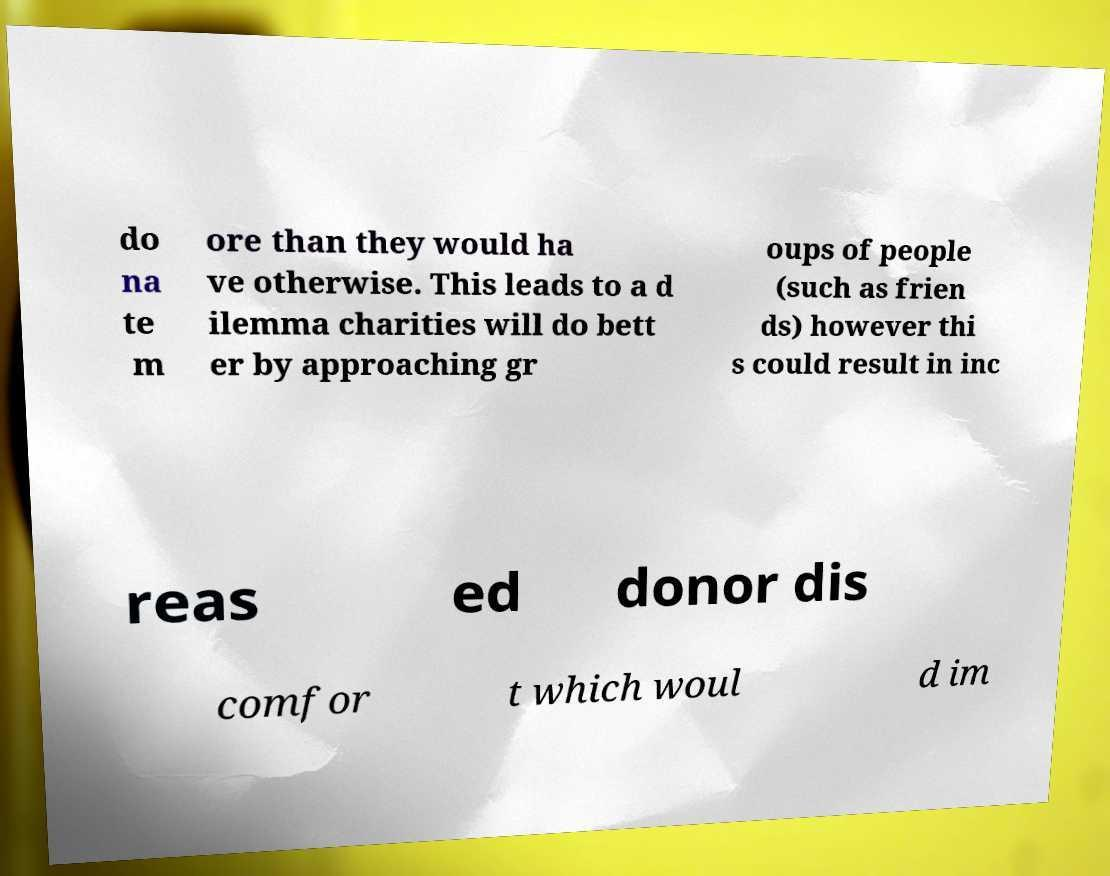Can you read and provide the text displayed in the image?This photo seems to have some interesting text. Can you extract and type it out for me? do na te m ore than they would ha ve otherwise. This leads to a d ilemma charities will do bett er by approaching gr oups of people (such as frien ds) however thi s could result in inc reas ed donor dis comfor t which woul d im 